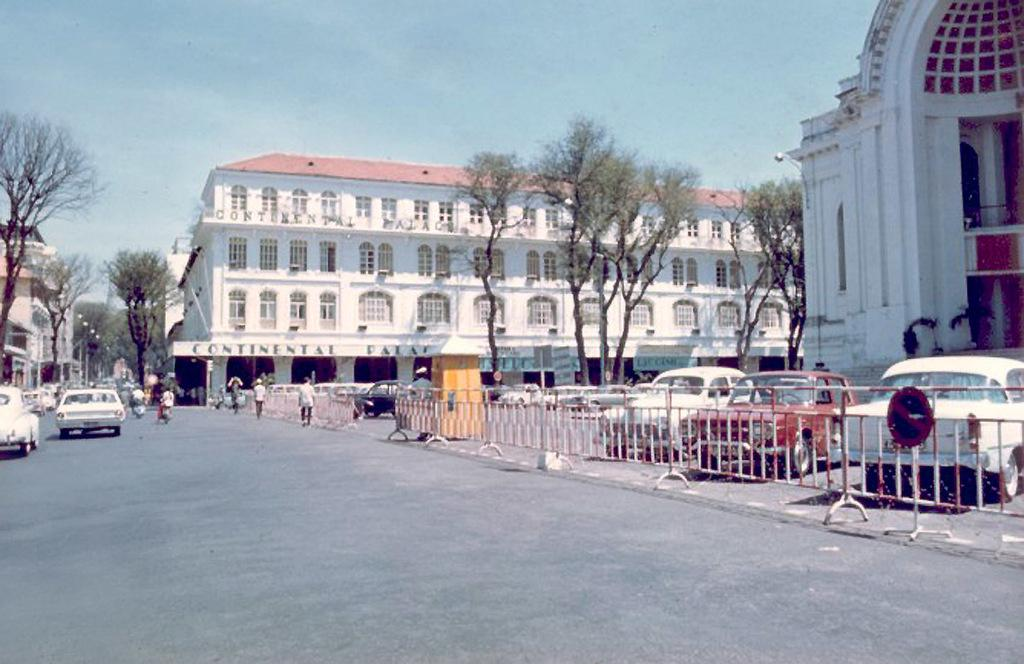What type of location is depicted in the image? The image is of a city. What architectural feature can be seen in the image? There are iron grills in the image. What type of signage is present in the image? There is a sign board in the image. What structures are visible in the image? There are buildings in the image. What type of vegetation is present in the image? There are trees in the image. What type of vertical structures are present in the image? There are poles in the image. What type of illumination is present in the image? There are lights in the image. Are there any people visible in the image? Yes, there is a group of people in the image. What type of transportation is present in the image? There are vehicles on the road in the image. What can be seen in the background of the image? The sky is visible in the background of the image. What type of glass can be seen in the image? There is no glass present in the image. How many books are visible in the image? There are no books visible in the image. 